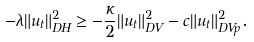Convert formula to latex. <formula><loc_0><loc_0><loc_500><loc_500>- \lambda \| u _ { t } \| _ { \L D H } ^ { 2 } \geq - \frac { \kappa } { 2 } \| u _ { t } \| _ { \L D V } ^ { 2 } - c \| u _ { t } \| _ { \L D V p } ^ { 2 } .</formula> 